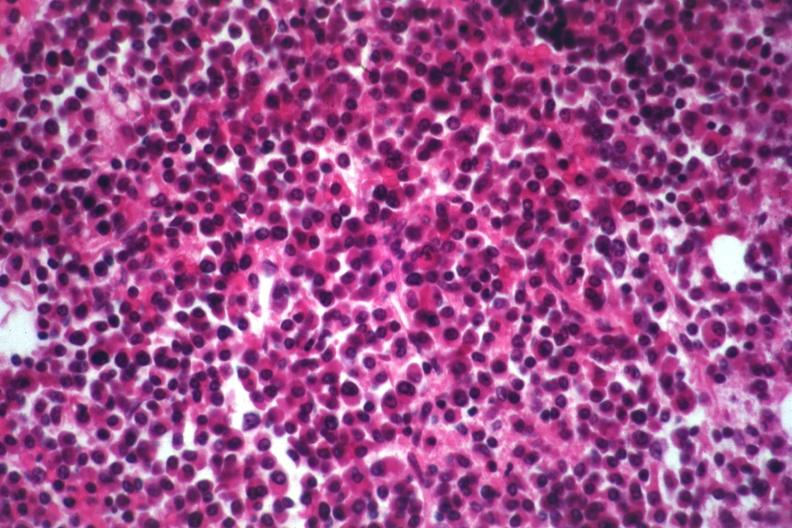s hematologic present?
Answer the question using a single word or phrase. Yes 